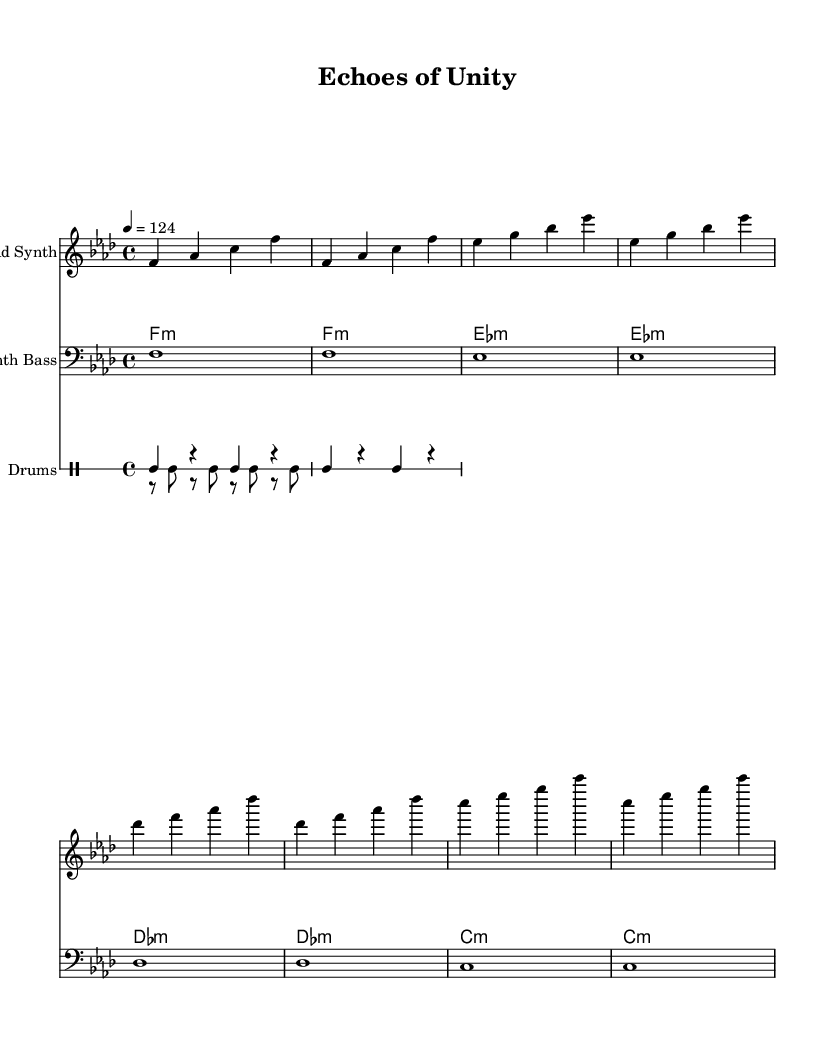What is the key signature of this music? The key signature is F minor, which is indicated by four flats in the staff before the notes start.
Answer: F minor What is the time signature of the piece? The time signature is indicated as 4/4, meaning there are four beats in each measure and the quarter note receives one beat.
Answer: 4/4 What is the tempo marking of this composition? The tempo marking states "4 = 124," which indicates the beats per minute.
Answer: 124 How many measures are in the lead synth part? Counting the notes and rests in the lead synth part reveals there are eight measures total.
Answer: 8 What types of instruments are included in this score? The score includes a lead synth, synth bass, and drums, which comprise two percussion voices (kick and hi-hat).
Answer: Lead Synth, Synth Bass, Drums What chord progression is used in the synth pad section? The synth pad section outlines a progression consisting of F minor, E flat minor, D flat minor, and C minor chords in a repeated cycle throughout.
Answer: F minor, E flat minor, D flat minor, C minor How is the kick drum pattern structured? The kick drum is structured with a repetitive pattern starting with a bass drum note followed by a rest. This pattern consists of two cycles within the two measures specified.
Answer: Repetitive bass drum pattern 